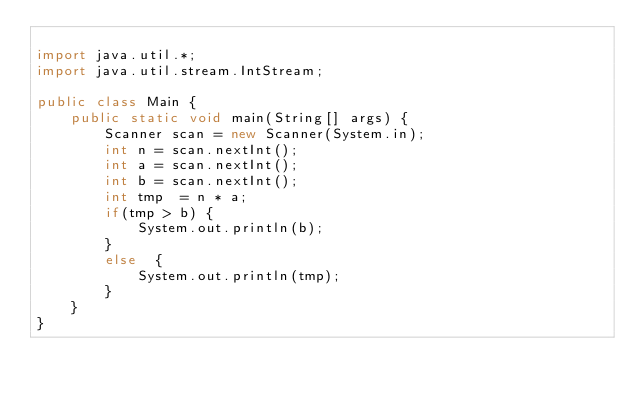Convert code to text. <code><loc_0><loc_0><loc_500><loc_500><_Java_>
import java.util.*;
import java.util.stream.IntStream;

public class Main {
    public static void main(String[] args) {
        Scanner scan = new Scanner(System.in);
        int n = scan.nextInt();
        int a = scan.nextInt();
        int b = scan.nextInt();
        int tmp  = n * a;
        if(tmp > b) {
            System.out.println(b);
        }
        else  {
            System.out.println(tmp);
        }
    }
}
</code> 